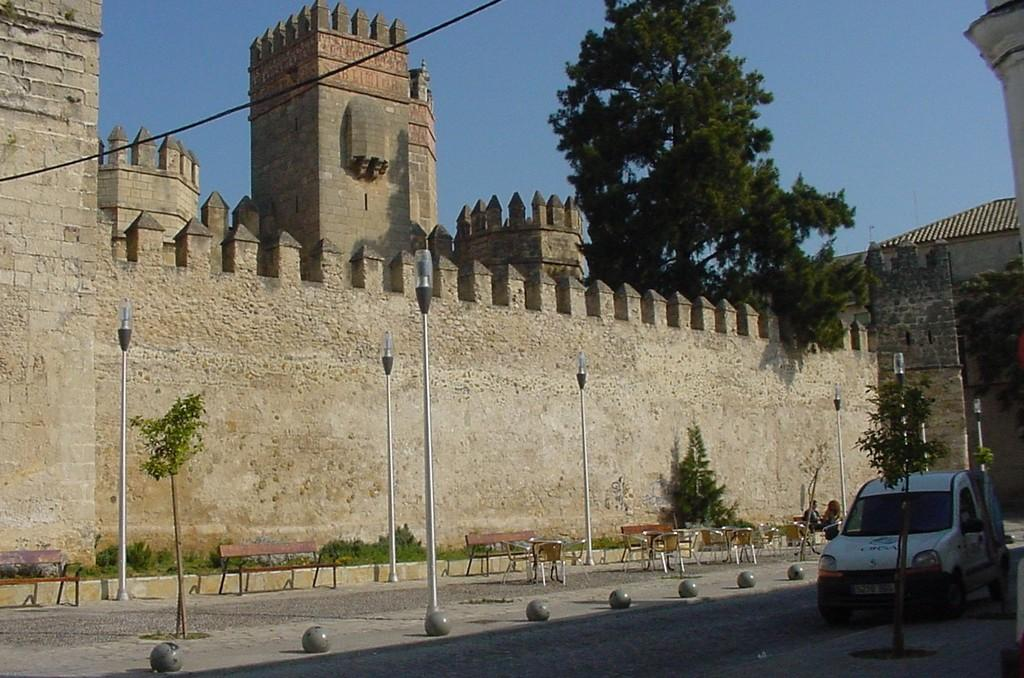What type of structure is visible in the picture? There is a fort in the picture. What type of vegetation can be seen in the picture? There are plants and trees in the picture. What architectural features are present in the picture? There are poles in the picture. What are the people in the picture doing? There are persons sitting on benches in the picture. What type of vehicle is parked on the right side of the picture? There is a white-colored car parked on the right side of the picture. What type of reward is being given to the plants in the picture? There is no reward being given to the plants in the picture; they are simply part of the natural environment. 